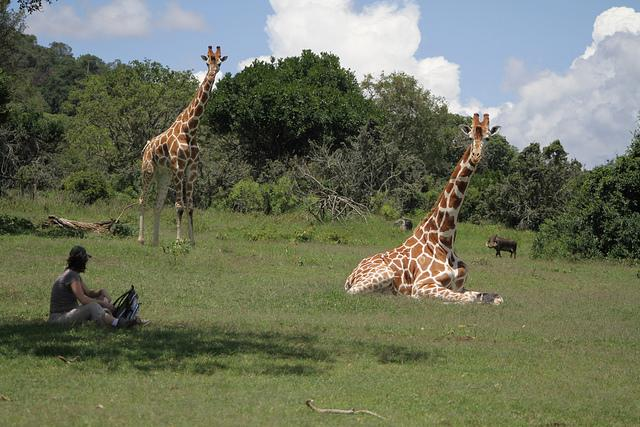Where is the person in?

Choices:
A) farm
B) barn
C) zoo
D) wilderness wilderness 